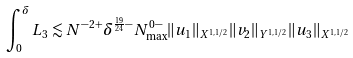Convert formula to latex. <formula><loc_0><loc_0><loc_500><loc_500>\int _ { 0 } ^ { \delta } L _ { 3 } \lesssim N ^ { - 2 + } \delta ^ { \frac { 1 9 } { 2 4 } - } N _ { \max } ^ { 0 - } \| u _ { 1 } \| _ { X ^ { 1 , 1 / 2 } } \| v _ { 2 } \| _ { Y ^ { 1 , 1 / 2 } } \| u _ { 3 } \| _ { X ^ { 1 , 1 / 2 } }</formula> 